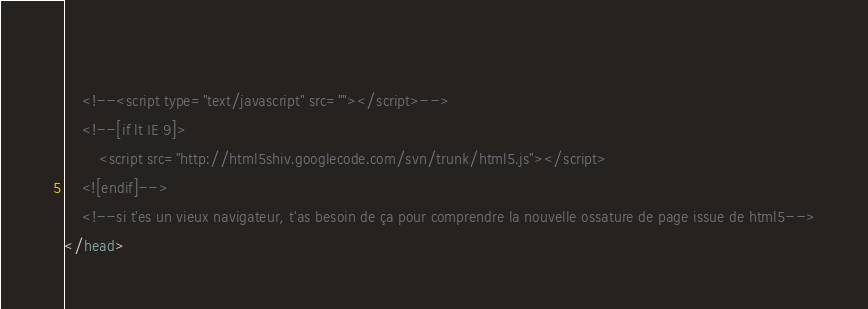Convert code to text. <code><loc_0><loc_0><loc_500><loc_500><_HTML_>    
    <!--<script type="text/javascript" src=""></script>-->
    <!--[if lt IE 9]>
		<script src="http://html5shiv.googlecode.com/svn/trunk/html5.js"></script>
	<![endif]-->
    <!--si t'es un vieux navigateur, t'as besoin de ça pour comprendre la nouvelle ossature de page issue de html5-->
</head></code> 